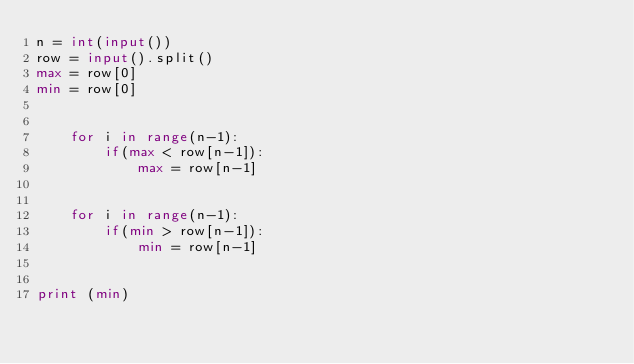<code> <loc_0><loc_0><loc_500><loc_500><_Python_>n = int(input()) 
row = input().split()
max = row[0]
min = row[0]


    for i in range(n-1):
        if(max < row[n-1]):
            max = row[n-1]


    for i in range(n-1):
        if(min > row[n-1]):
            min = row[n-1]


print (min)
    


</code> 